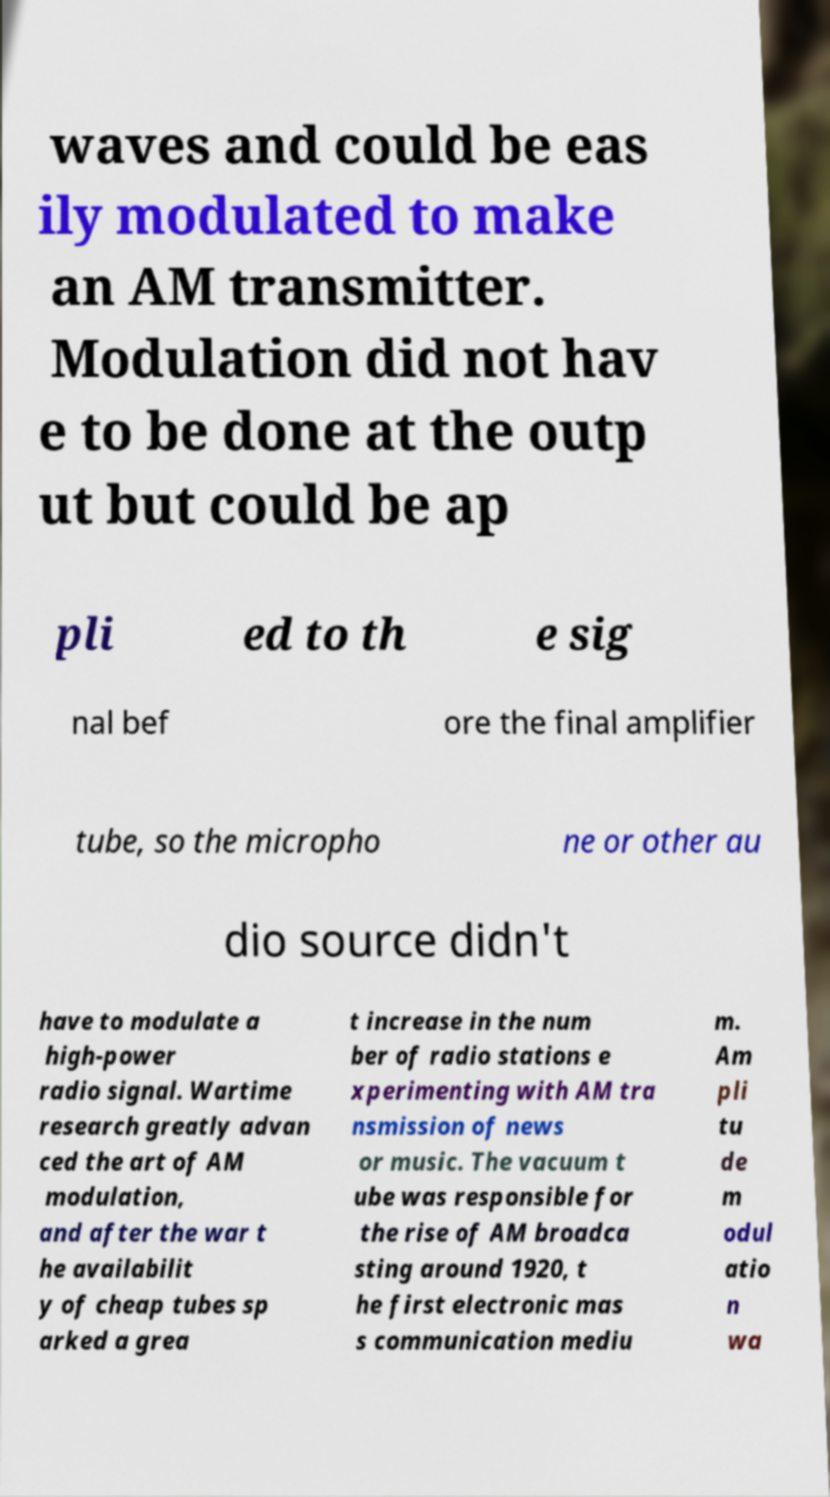I need the written content from this picture converted into text. Can you do that? waves and could be eas ily modulated to make an AM transmitter. Modulation did not hav e to be done at the outp ut but could be ap pli ed to th e sig nal bef ore the final amplifier tube, so the micropho ne or other au dio source didn't have to modulate a high-power radio signal. Wartime research greatly advan ced the art of AM modulation, and after the war t he availabilit y of cheap tubes sp arked a grea t increase in the num ber of radio stations e xperimenting with AM tra nsmission of news or music. The vacuum t ube was responsible for the rise of AM broadca sting around 1920, t he first electronic mas s communication mediu m. Am pli tu de m odul atio n wa 